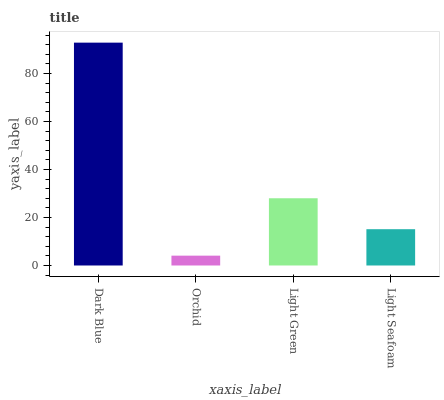Is Orchid the minimum?
Answer yes or no. Yes. Is Dark Blue the maximum?
Answer yes or no. Yes. Is Light Green the minimum?
Answer yes or no. No. Is Light Green the maximum?
Answer yes or no. No. Is Light Green greater than Orchid?
Answer yes or no. Yes. Is Orchid less than Light Green?
Answer yes or no. Yes. Is Orchid greater than Light Green?
Answer yes or no. No. Is Light Green less than Orchid?
Answer yes or no. No. Is Light Green the high median?
Answer yes or no. Yes. Is Light Seafoam the low median?
Answer yes or no. Yes. Is Light Seafoam the high median?
Answer yes or no. No. Is Dark Blue the low median?
Answer yes or no. No. 